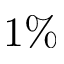Convert formula to latex. <formula><loc_0><loc_0><loc_500><loc_500>1 \%</formula> 